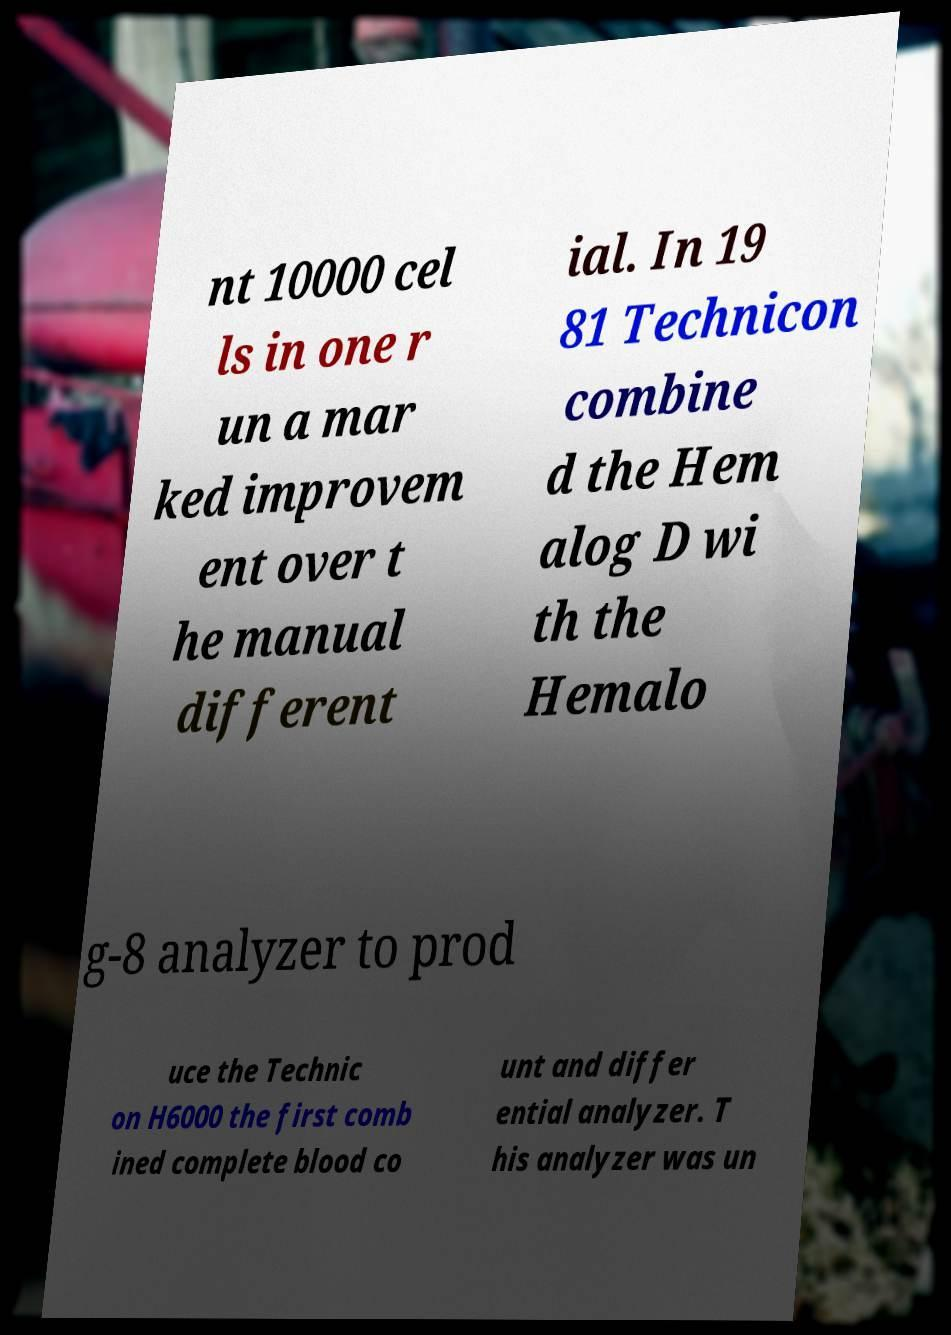Please identify and transcribe the text found in this image. nt 10000 cel ls in one r un a mar ked improvem ent over t he manual different ial. In 19 81 Technicon combine d the Hem alog D wi th the Hemalo g-8 analyzer to prod uce the Technic on H6000 the first comb ined complete blood co unt and differ ential analyzer. T his analyzer was un 